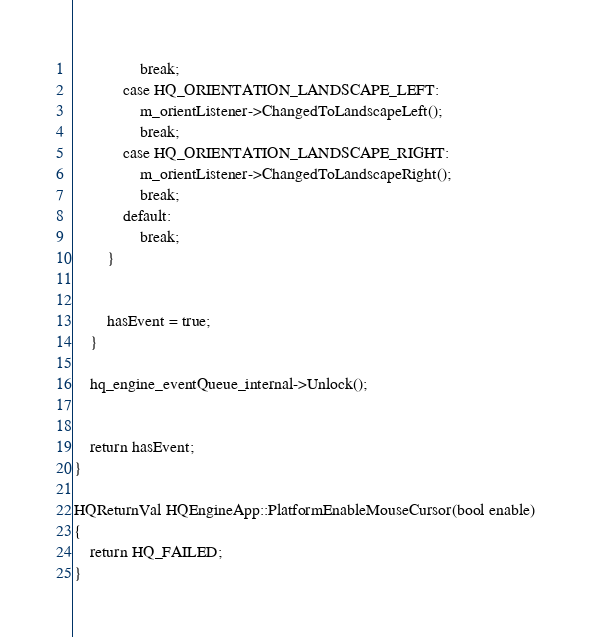<code> <loc_0><loc_0><loc_500><loc_500><_ObjectiveC_>				break;
			case HQ_ORIENTATION_LANDSCAPE_LEFT:
				m_orientListener->ChangedToLandscapeLeft();
				break;
			case HQ_ORIENTATION_LANDSCAPE_RIGHT:
				m_orientListener->ChangedToLandscapeRight();
				break;
			default:
				break;
		}
		
		
		hasEvent = true;
	}
	
	hq_engine_eventQueue_internal->Unlock();	

	
	return hasEvent;
}

HQReturnVal HQEngineApp::PlatformEnableMouseCursor(bool enable)
{
	return HQ_FAILED;
}
</code> 